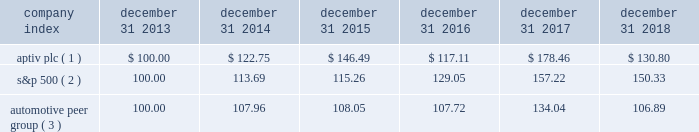Part ii item 5 .
Market for registrant 2019s common equity , related stockholder matters and issuer purchases of equity securities our ordinary shares have been publicly traded since november 17 , 2011 when our ordinary shares were listed and began trading on the new york stock exchange ( 201cnyse 201d ) under the symbol 201cdlph . 201d on december 4 , 2017 , following the spin-off of delphi technologies , the company changed its name to aptiv plc and its nyse symbol to 201captv . 201d as of january 25 , 2019 , there were 2 shareholders of record of our ordinary shares .
The following graph reflects the comparative changes in the value from december 31 , 2013 through december 31 , 2018 , assuming an initial investment of $ 100 and the reinvestment of dividends , if any in ( 1 ) our ordinary shares , ( 2 ) the s&p 500 index and ( 3 ) the automotive peer group .
Historical share prices of our ordinary shares have been adjusted to reflect the separation .
Historical performance may not be indicative of future shareholder returns .
Stock performance graph * $ 100 invested on december 31 , 2013 in our stock or in the relevant index , including reinvestment of dividends .
Fiscal year ended december 31 , 2018 .
( 1 ) aptiv plc , adjusted for the distribution of delphi technologies on december 4 , 2017 ( 2 ) s&p 500 2013 standard & poor 2019s 500 total return index ( 3 ) automotive peer group 2013 adient plc , american axle & manufacturing holdings inc , aptiv plc , borgwarner inc , cooper tire & rubber co , cooper- standard holdings inc , dana inc , dorman products inc , ford motor co , garrett motion inc. , general motors co , gentex corp , gentherm inc , genuine parts co , goodyear tire & rubber co , lear corp , lkq corp , meritor inc , motorcar parts of america inc , standard motor products inc , stoneridge inc , superior industries international inc , tenneco inc , tesla inc , tower international inc , visteon corp , wabco holdings inc company index december 31 , december 31 , december 31 , december 31 , december 31 , december 31 .

What is the highest return for the second year of the investment? 
Rationale: it is the maximum value turned into a percentage to represent the return .
Computations: (146.49 - 100)
Answer: 46.49. 